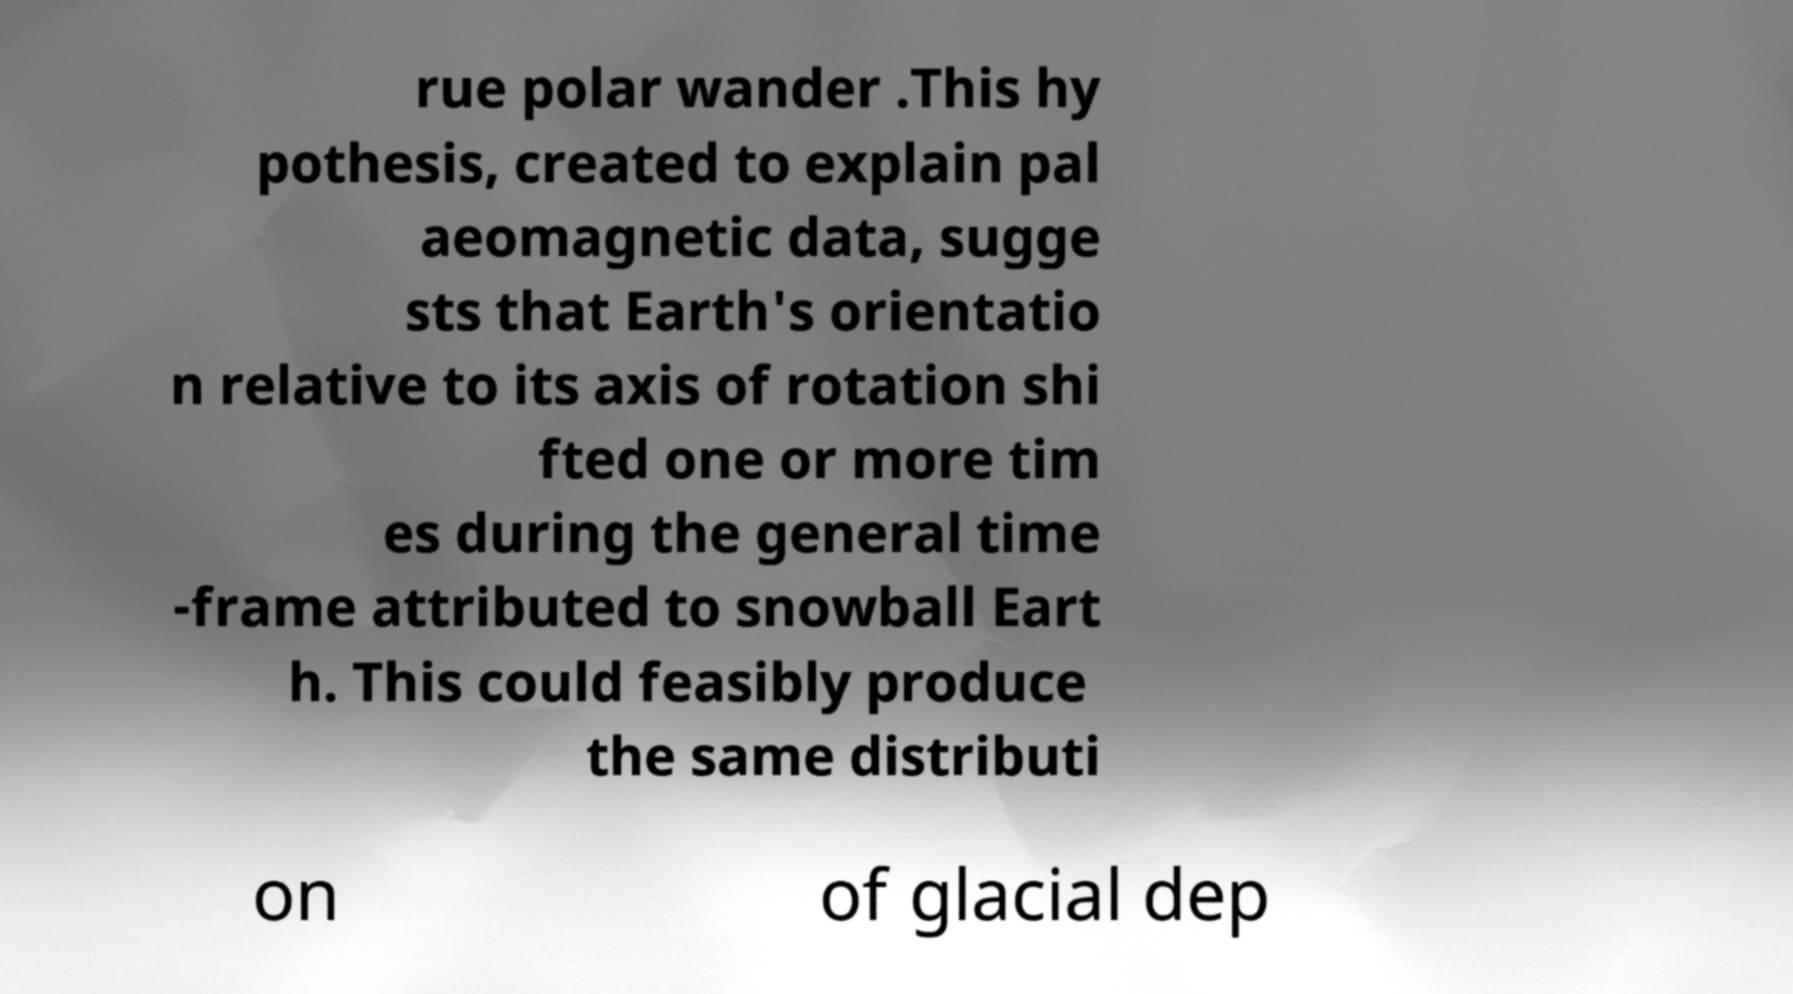For documentation purposes, I need the text within this image transcribed. Could you provide that? rue polar wander .This hy pothesis, created to explain pal aeomagnetic data, sugge sts that Earth's orientatio n relative to its axis of rotation shi fted one or more tim es during the general time -frame attributed to snowball Eart h. This could feasibly produce the same distributi on of glacial dep 